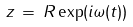Convert formula to latex. <formula><loc_0><loc_0><loc_500><loc_500>z \, = \, R \exp ( i \omega ( t ) )</formula> 